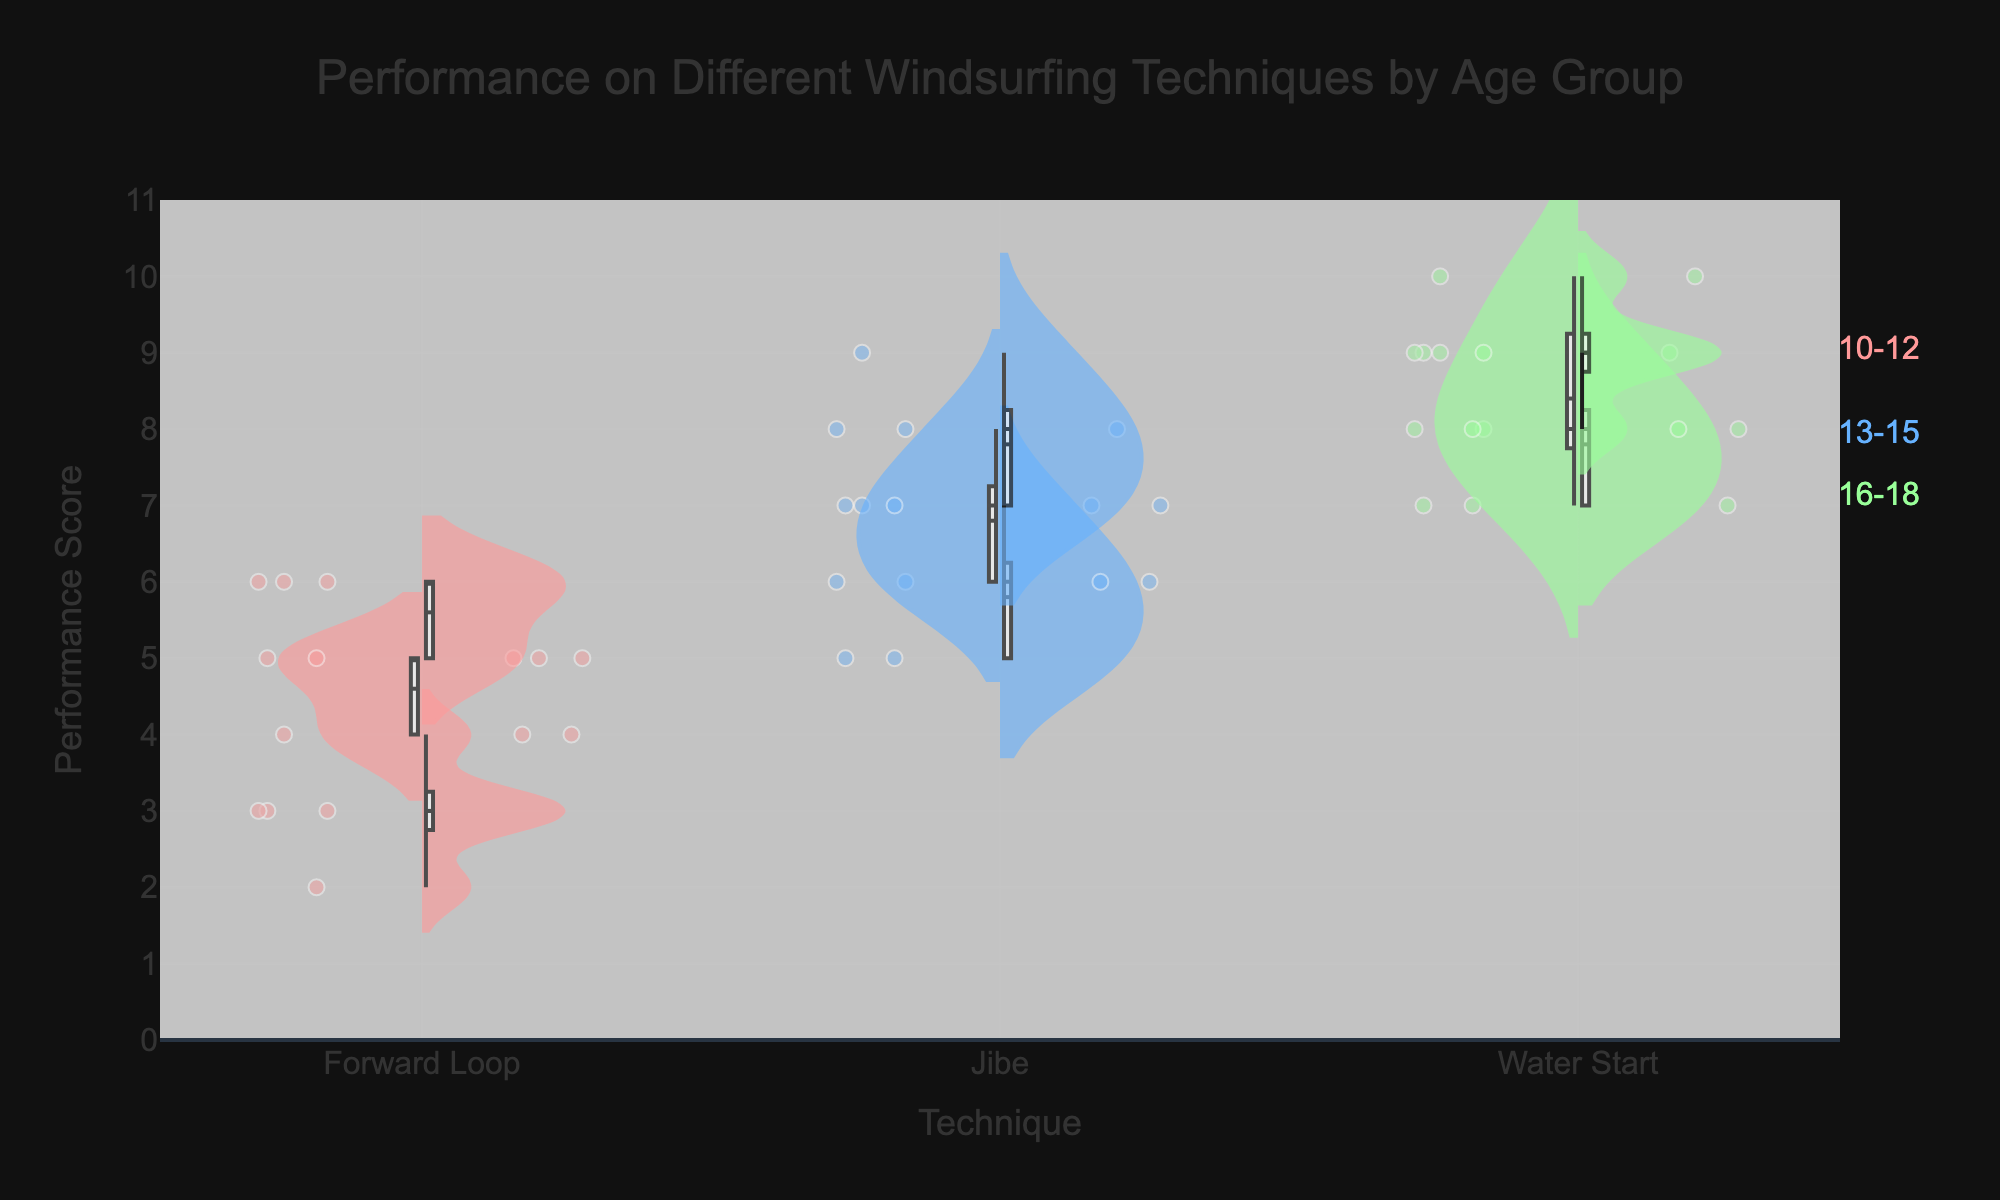What age group has the highest average performance score for the Forward Loop technique? To determine the age group with the highest average performance score for the Forward Loop technique, look at the central tendency of the violin plots for each age group in the Forward Loop category. The age group 16-18 has the highest peaks and the largest central tendency.
Answer: 16-18 Which technique shows the highest performance scores for the 10-12 age group? For the 10-12 age group, inspect each respective violin plot to identify the maximum score. The Water Start technique shows the highest performance scores among the three techniques for this age group.
Answer: Water Start How does the performance of the Jibe technique compare between the 13-15 and 16-18 age groups? Compare the height and concentration of points in the violin plots for the Jibe technique between the 13-15 and 16-18 age groups. The 16-18 age group shows higher concentrations at upper scores, indicating better performance.
Answer: The 16-18 age group performs better What is the range (difference between highest and lowest values) of performance scores for the Forward Loop technique in the 10-12 age group? To determine the range, look at the spread of points in the violin plot for the Forward Loop in the 10-12 age group. The scores range from 2 to 4, so the difference is 4 - 2 = 2.
Answer: 2 Which age group has the widest spread of performance scores for the Water Start technique? To find the widest spread, examine the violin plots for the Water Start technique across all age groups and note the one with the longest vertical range. The 16-18 age group displays the widest spread.
Answer: 16-18 Between the Water Start and Forward Loop techniques, which has a higher median performance score for the 13-15 age group? The median is the value separating the higher half from the lower half of the data points. By comparing the central white lines of the box plots within the violins, the Water Start technique has a higher median performance score for the 13-15 age group compared to the Forward Loop.
Answer: Water Start What trend can you observe in performance scores as age groups increase, for the Jibe technique? Observing the violin plots for the Jibe technique across age groups, there is a trend showing an increase in performance scores as the age group increases, with the 16-18 age group having the highest scores.
Answer: Performance improves with age Which technique has the smallest variation in performance scores for the 16-18 age group? Look at the violin plots for the 16-18 age group and identify the technique with the narrowest band of scores. The Water Start technique has the smallest variation.
Answer: Water Start 